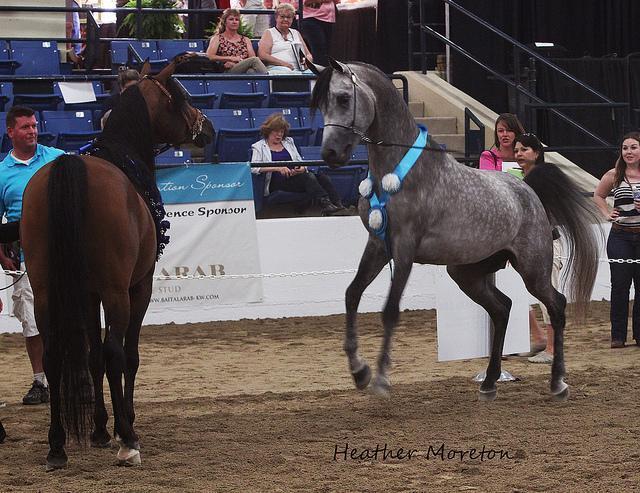How many benches are in the photo?
Give a very brief answer. 2. How many people are there?
Give a very brief answer. 5. How many horses are visible?
Give a very brief answer. 2. 